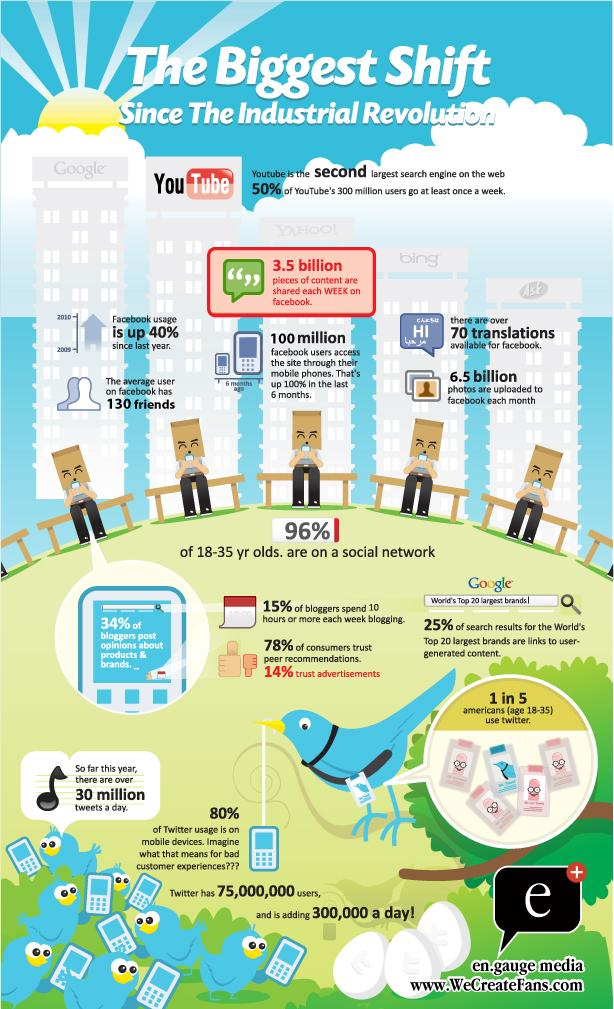Indicate a few pertinent items in this graphic. Approximately 6.5 billion photos are uploaded to Facebook each month. A survey revealed that 34% of bloggers post opinions about products and brands. According to a survey, approximately 20% of users do not use Twitter on their mobile devices. A recent survey has revealed that only 4% of individuals aged 18-35 years old are not on a social network. 